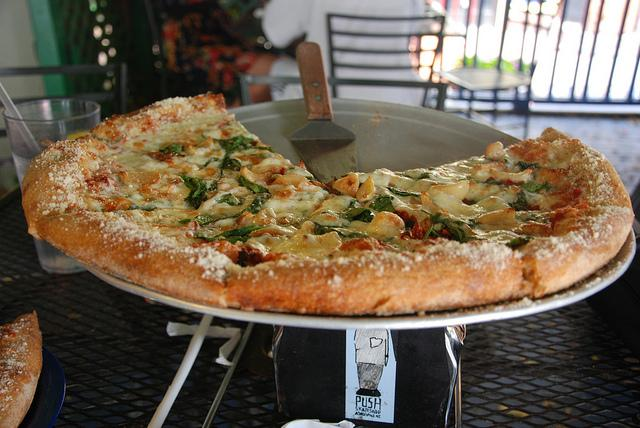What ingredients are on the pizza? spinach cheese 